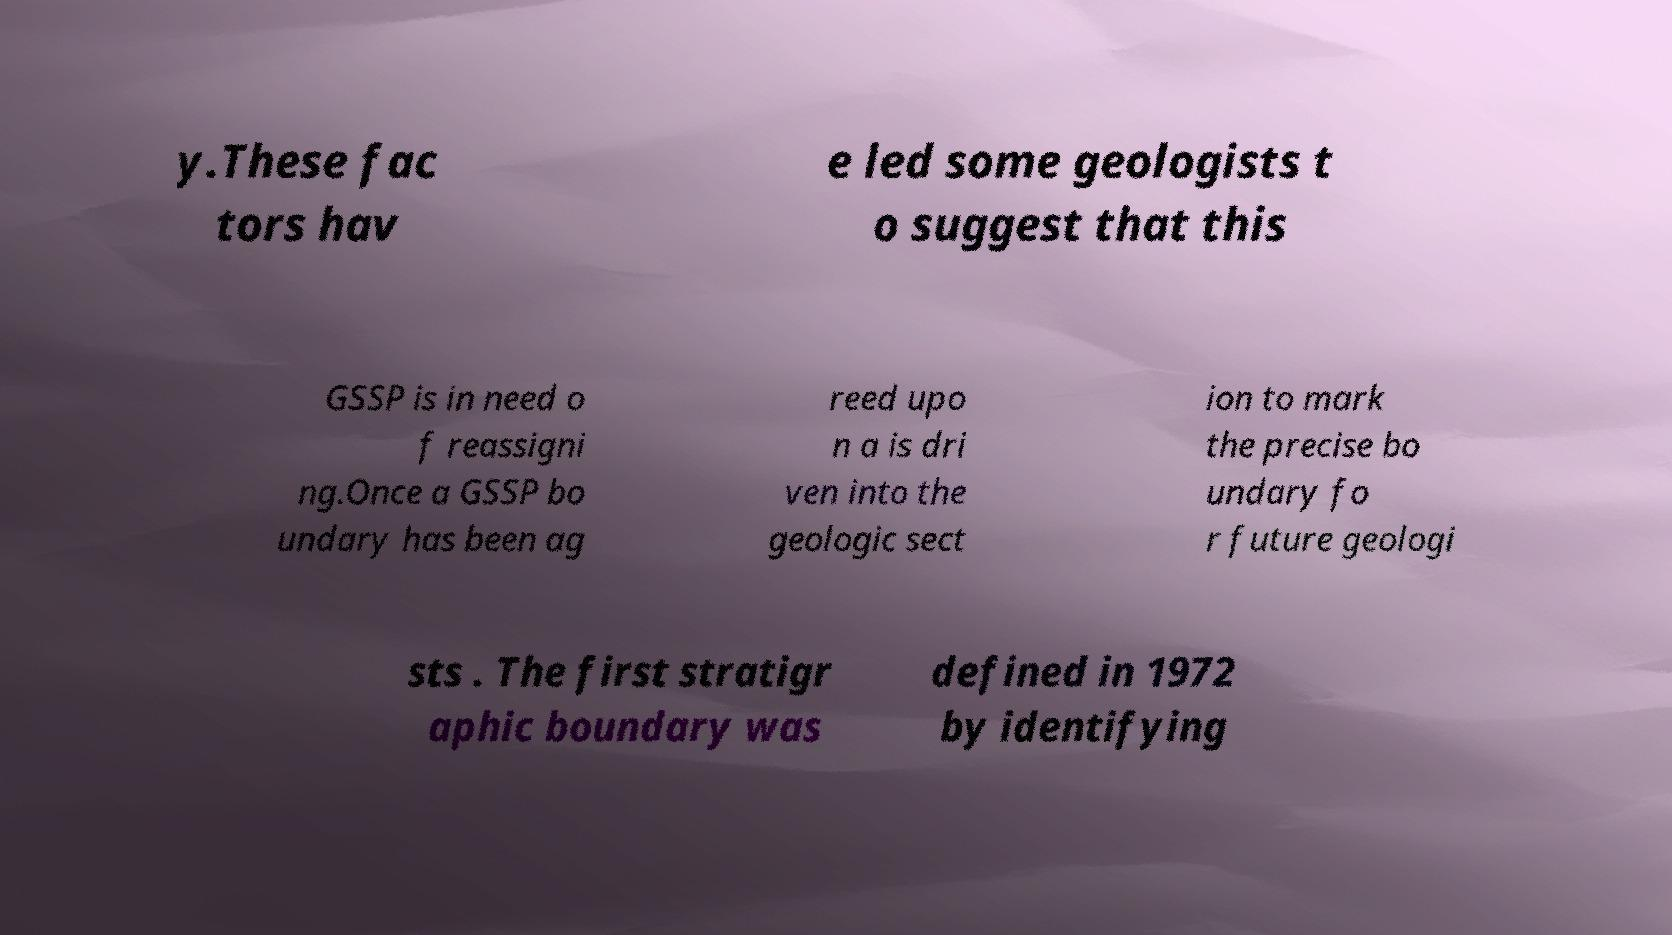Could you assist in decoding the text presented in this image and type it out clearly? y.These fac tors hav e led some geologists t o suggest that this GSSP is in need o f reassigni ng.Once a GSSP bo undary has been ag reed upo n a is dri ven into the geologic sect ion to mark the precise bo undary fo r future geologi sts . The first stratigr aphic boundary was defined in 1972 by identifying 